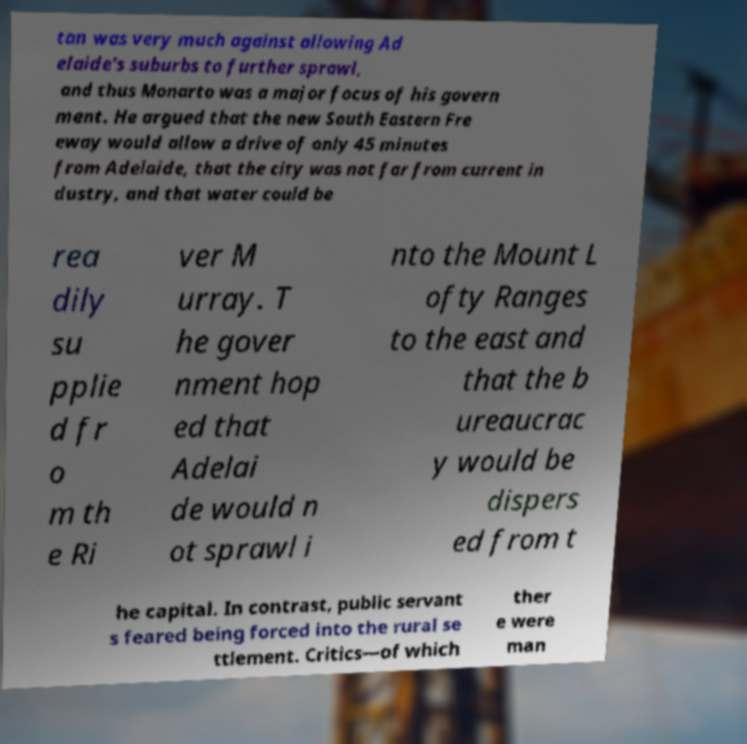Could you assist in decoding the text presented in this image and type it out clearly? tan was very much against allowing Ad elaide's suburbs to further sprawl, and thus Monarto was a major focus of his govern ment. He argued that the new South Eastern Fre eway would allow a drive of only 45 minutes from Adelaide, that the city was not far from current in dustry, and that water could be rea dily su pplie d fr o m th e Ri ver M urray. T he gover nment hop ed that Adelai de would n ot sprawl i nto the Mount L ofty Ranges to the east and that the b ureaucrac y would be dispers ed from t he capital. In contrast, public servant s feared being forced into the rural se ttlement. Critics—of which ther e were man 